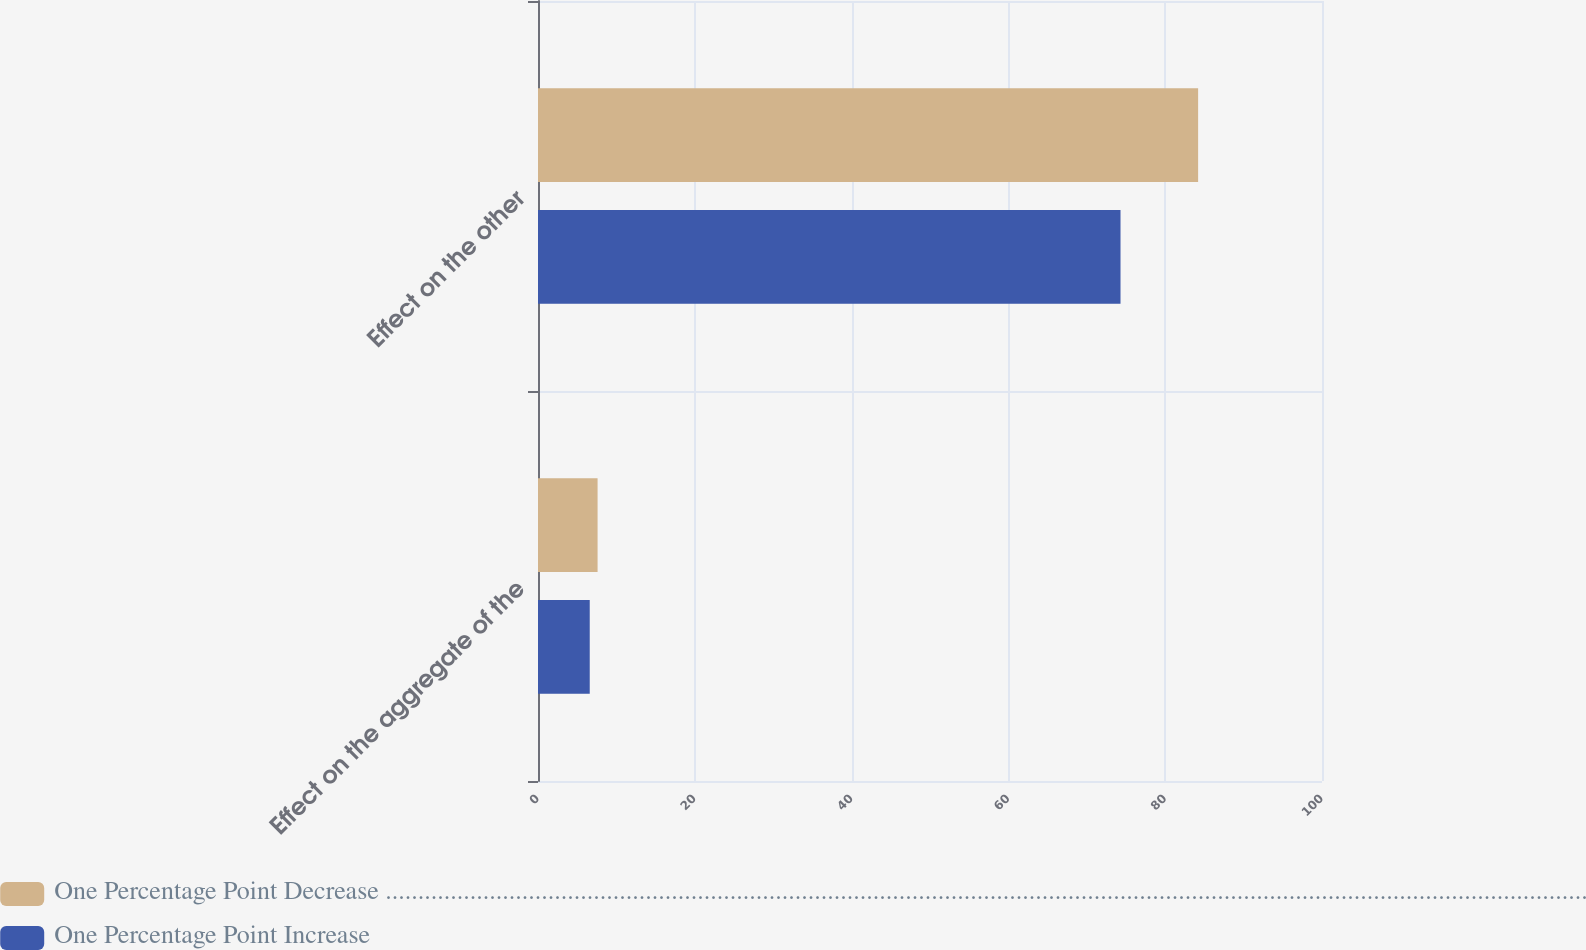Convert chart to OTSL. <chart><loc_0><loc_0><loc_500><loc_500><stacked_bar_chart><ecel><fcel>Effect on the aggregate of the<fcel>Effect on the other<nl><fcel>One Percentage Point Decrease .........................................................................................................................................................................................<fcel>7.6<fcel>84.2<nl><fcel>One Percentage Point Increase<fcel>6.6<fcel>74.3<nl></chart> 